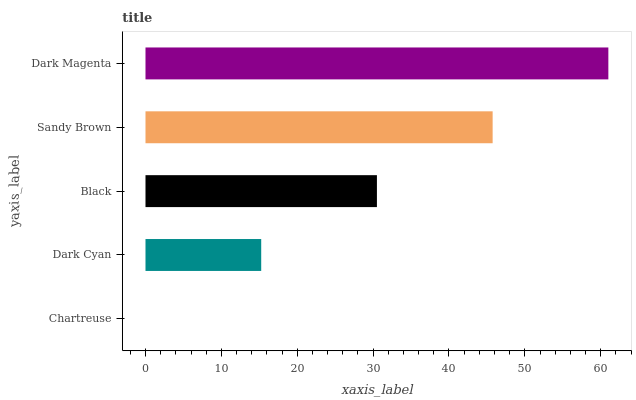Is Chartreuse the minimum?
Answer yes or no. Yes. Is Dark Magenta the maximum?
Answer yes or no. Yes. Is Dark Cyan the minimum?
Answer yes or no. No. Is Dark Cyan the maximum?
Answer yes or no. No. Is Dark Cyan greater than Chartreuse?
Answer yes or no. Yes. Is Chartreuse less than Dark Cyan?
Answer yes or no. Yes. Is Chartreuse greater than Dark Cyan?
Answer yes or no. No. Is Dark Cyan less than Chartreuse?
Answer yes or no. No. Is Black the high median?
Answer yes or no. Yes. Is Black the low median?
Answer yes or no. Yes. Is Dark Cyan the high median?
Answer yes or no. No. Is Dark Magenta the low median?
Answer yes or no. No. 